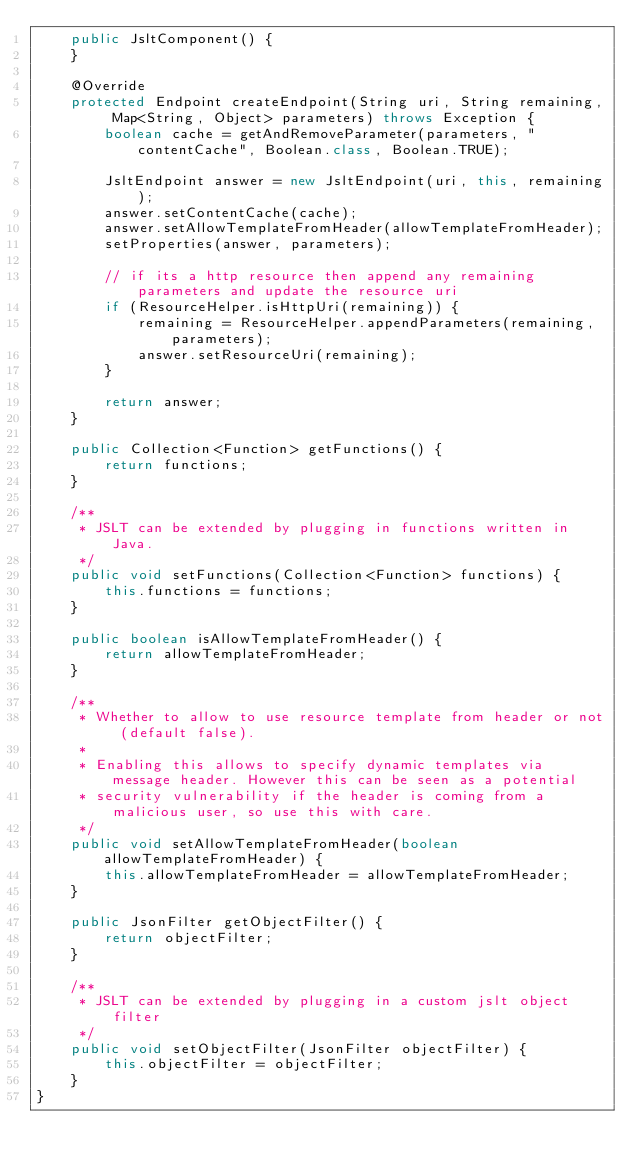<code> <loc_0><loc_0><loc_500><loc_500><_Java_>    public JsltComponent() {
    }

    @Override
    protected Endpoint createEndpoint(String uri, String remaining, Map<String, Object> parameters) throws Exception {
        boolean cache = getAndRemoveParameter(parameters, "contentCache", Boolean.class, Boolean.TRUE);

        JsltEndpoint answer = new JsltEndpoint(uri, this, remaining);
        answer.setContentCache(cache);
        answer.setAllowTemplateFromHeader(allowTemplateFromHeader);
        setProperties(answer, parameters);

        // if its a http resource then append any remaining parameters and update the resource uri
        if (ResourceHelper.isHttpUri(remaining)) {
            remaining = ResourceHelper.appendParameters(remaining, parameters);
            answer.setResourceUri(remaining);
        }

        return answer;
    }

    public Collection<Function> getFunctions() {
        return functions;
    }

    /**
     * JSLT can be extended by plugging in functions written in Java.
     */
    public void setFunctions(Collection<Function> functions) {
        this.functions = functions;
    }

    public boolean isAllowTemplateFromHeader() {
        return allowTemplateFromHeader;
    }

    /**
     * Whether to allow to use resource template from header or not (default false).
     *
     * Enabling this allows to specify dynamic templates via message header. However this can be seen as a potential
     * security vulnerability if the header is coming from a malicious user, so use this with care.
     */
    public void setAllowTemplateFromHeader(boolean allowTemplateFromHeader) {
        this.allowTemplateFromHeader = allowTemplateFromHeader;
    }

    public JsonFilter getObjectFilter() {
        return objectFilter;
    }

    /**
     * JSLT can be extended by plugging in a custom jslt object filter
     */
    public void setObjectFilter(JsonFilter objectFilter) {
        this.objectFilter = objectFilter;
    }
}
</code> 